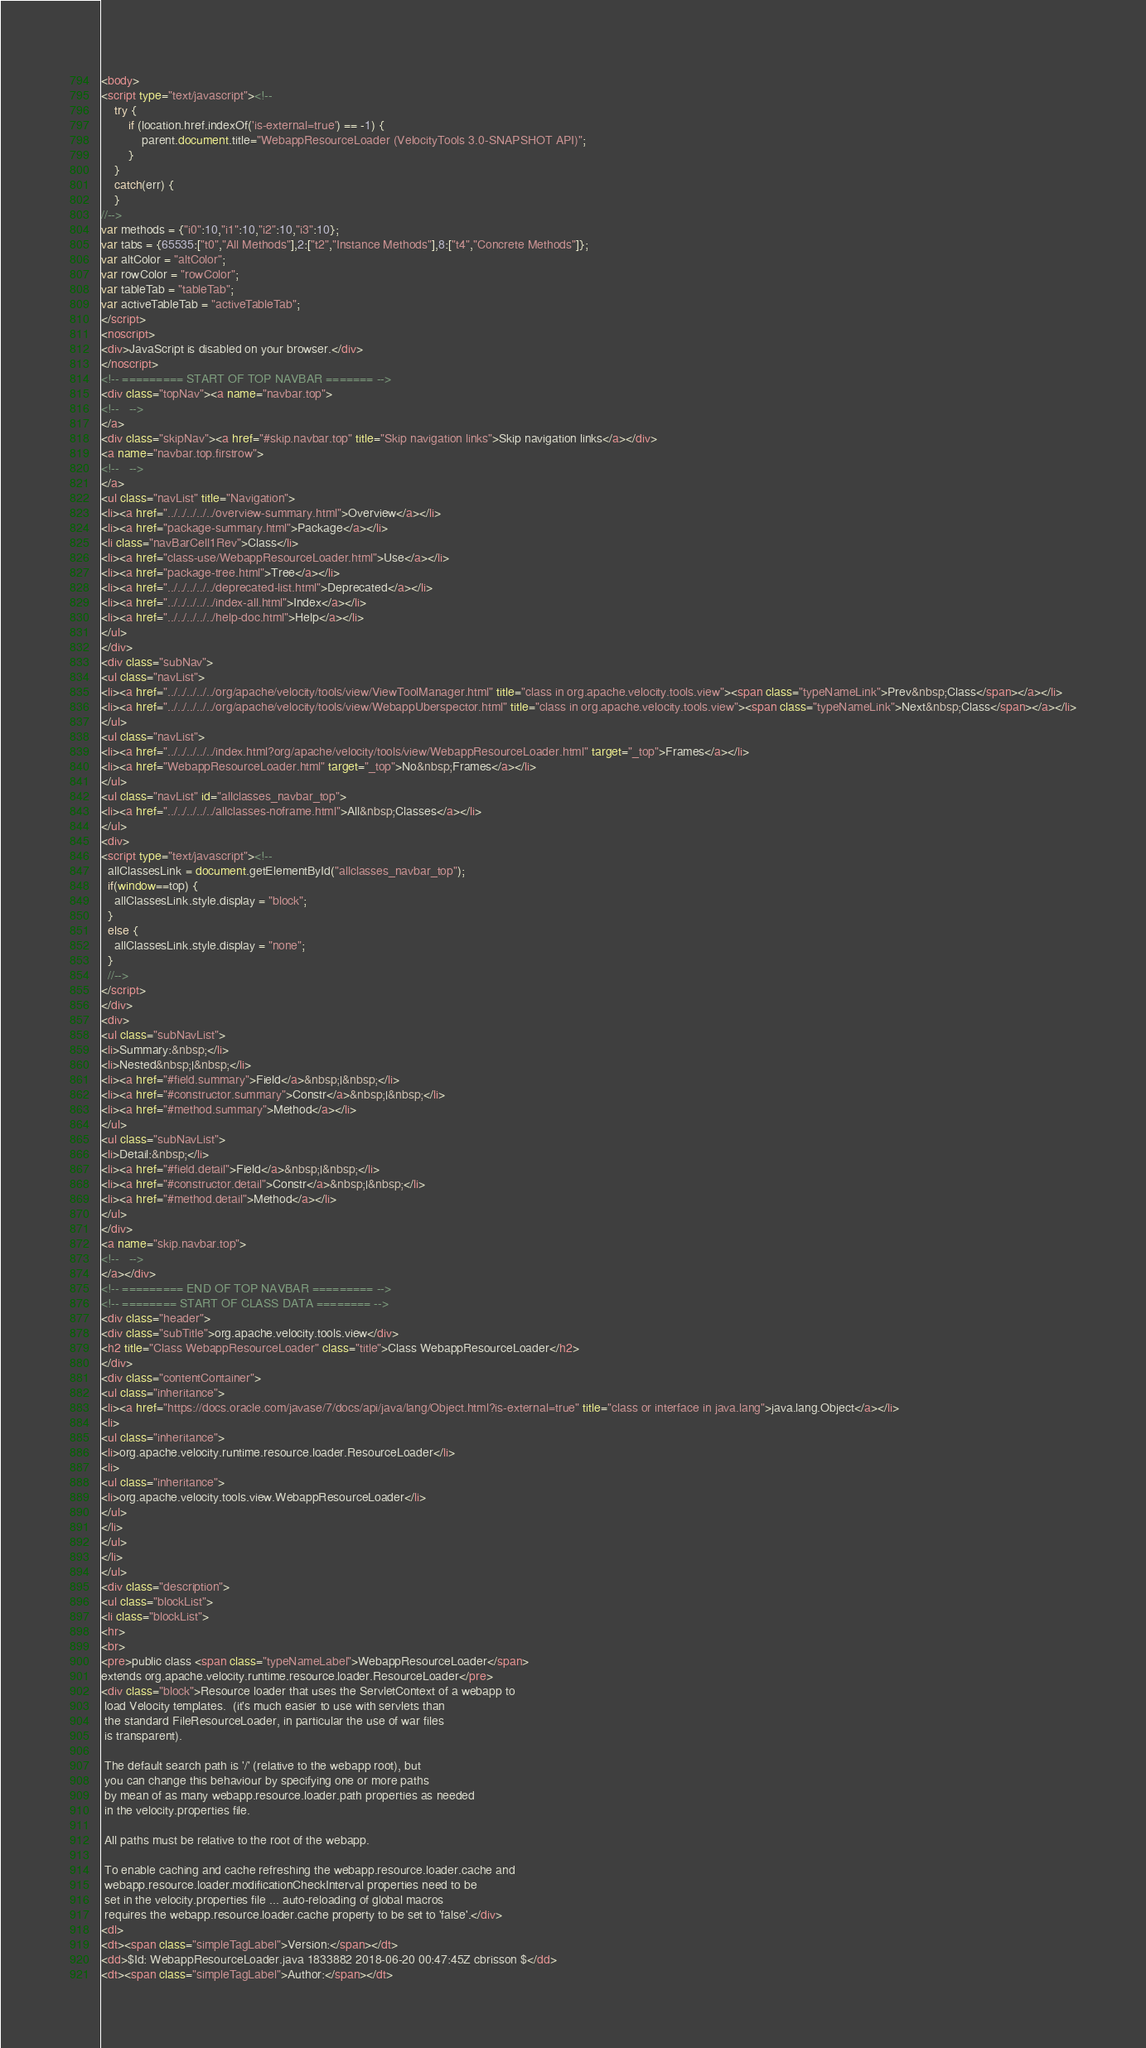<code> <loc_0><loc_0><loc_500><loc_500><_HTML_><body>
<script type="text/javascript"><!--
    try {
        if (location.href.indexOf('is-external=true') == -1) {
            parent.document.title="WebappResourceLoader (VelocityTools 3.0-SNAPSHOT API)";
        }
    }
    catch(err) {
    }
//-->
var methods = {"i0":10,"i1":10,"i2":10,"i3":10};
var tabs = {65535:["t0","All Methods"],2:["t2","Instance Methods"],8:["t4","Concrete Methods"]};
var altColor = "altColor";
var rowColor = "rowColor";
var tableTab = "tableTab";
var activeTableTab = "activeTableTab";
</script>
<noscript>
<div>JavaScript is disabled on your browser.</div>
</noscript>
<!-- ========= START OF TOP NAVBAR ======= -->
<div class="topNav"><a name="navbar.top">
<!--   -->
</a>
<div class="skipNav"><a href="#skip.navbar.top" title="Skip navigation links">Skip navigation links</a></div>
<a name="navbar.top.firstrow">
<!--   -->
</a>
<ul class="navList" title="Navigation">
<li><a href="../../../../../overview-summary.html">Overview</a></li>
<li><a href="package-summary.html">Package</a></li>
<li class="navBarCell1Rev">Class</li>
<li><a href="class-use/WebappResourceLoader.html">Use</a></li>
<li><a href="package-tree.html">Tree</a></li>
<li><a href="../../../../../deprecated-list.html">Deprecated</a></li>
<li><a href="../../../../../index-all.html">Index</a></li>
<li><a href="../../../../../help-doc.html">Help</a></li>
</ul>
</div>
<div class="subNav">
<ul class="navList">
<li><a href="../../../../../org/apache/velocity/tools/view/ViewToolManager.html" title="class in org.apache.velocity.tools.view"><span class="typeNameLink">Prev&nbsp;Class</span></a></li>
<li><a href="../../../../../org/apache/velocity/tools/view/WebappUberspector.html" title="class in org.apache.velocity.tools.view"><span class="typeNameLink">Next&nbsp;Class</span></a></li>
</ul>
<ul class="navList">
<li><a href="../../../../../index.html?org/apache/velocity/tools/view/WebappResourceLoader.html" target="_top">Frames</a></li>
<li><a href="WebappResourceLoader.html" target="_top">No&nbsp;Frames</a></li>
</ul>
<ul class="navList" id="allclasses_navbar_top">
<li><a href="../../../../../allclasses-noframe.html">All&nbsp;Classes</a></li>
</ul>
<div>
<script type="text/javascript"><!--
  allClassesLink = document.getElementById("allclasses_navbar_top");
  if(window==top) {
    allClassesLink.style.display = "block";
  }
  else {
    allClassesLink.style.display = "none";
  }
  //-->
</script>
</div>
<div>
<ul class="subNavList">
<li>Summary:&nbsp;</li>
<li>Nested&nbsp;|&nbsp;</li>
<li><a href="#field.summary">Field</a>&nbsp;|&nbsp;</li>
<li><a href="#constructor.summary">Constr</a>&nbsp;|&nbsp;</li>
<li><a href="#method.summary">Method</a></li>
</ul>
<ul class="subNavList">
<li>Detail:&nbsp;</li>
<li><a href="#field.detail">Field</a>&nbsp;|&nbsp;</li>
<li><a href="#constructor.detail">Constr</a>&nbsp;|&nbsp;</li>
<li><a href="#method.detail">Method</a></li>
</ul>
</div>
<a name="skip.navbar.top">
<!--   -->
</a></div>
<!-- ========= END OF TOP NAVBAR ========= -->
<!-- ======== START OF CLASS DATA ======== -->
<div class="header">
<div class="subTitle">org.apache.velocity.tools.view</div>
<h2 title="Class WebappResourceLoader" class="title">Class WebappResourceLoader</h2>
</div>
<div class="contentContainer">
<ul class="inheritance">
<li><a href="https://docs.oracle.com/javase/7/docs/api/java/lang/Object.html?is-external=true" title="class or interface in java.lang">java.lang.Object</a></li>
<li>
<ul class="inheritance">
<li>org.apache.velocity.runtime.resource.loader.ResourceLoader</li>
<li>
<ul class="inheritance">
<li>org.apache.velocity.tools.view.WebappResourceLoader</li>
</ul>
</li>
</ul>
</li>
</ul>
<div class="description">
<ul class="blockList">
<li class="blockList">
<hr>
<br>
<pre>public class <span class="typeNameLabel">WebappResourceLoader</span>
extends org.apache.velocity.runtime.resource.loader.ResourceLoader</pre>
<div class="block">Resource loader that uses the ServletContext of a webapp to
 load Velocity templates.  (it's much easier to use with servlets than
 the standard FileResourceLoader, in particular the use of war files
 is transparent).

 The default search path is '/' (relative to the webapp root), but
 you can change this behaviour by specifying one or more paths
 by mean of as many webapp.resource.loader.path properties as needed
 in the velocity.properties file.

 All paths must be relative to the root of the webapp.

 To enable caching and cache refreshing the webapp.resource.loader.cache and
 webapp.resource.loader.modificationCheckInterval properties need to be
 set in the velocity.properties file ... auto-reloading of global macros
 requires the webapp.resource.loader.cache property to be set to 'false'.</div>
<dl>
<dt><span class="simpleTagLabel">Version:</span></dt>
<dd>$Id: WebappResourceLoader.java 1833882 2018-06-20 00:47:45Z cbrisson $</dd>
<dt><span class="simpleTagLabel">Author:</span></dt></code> 